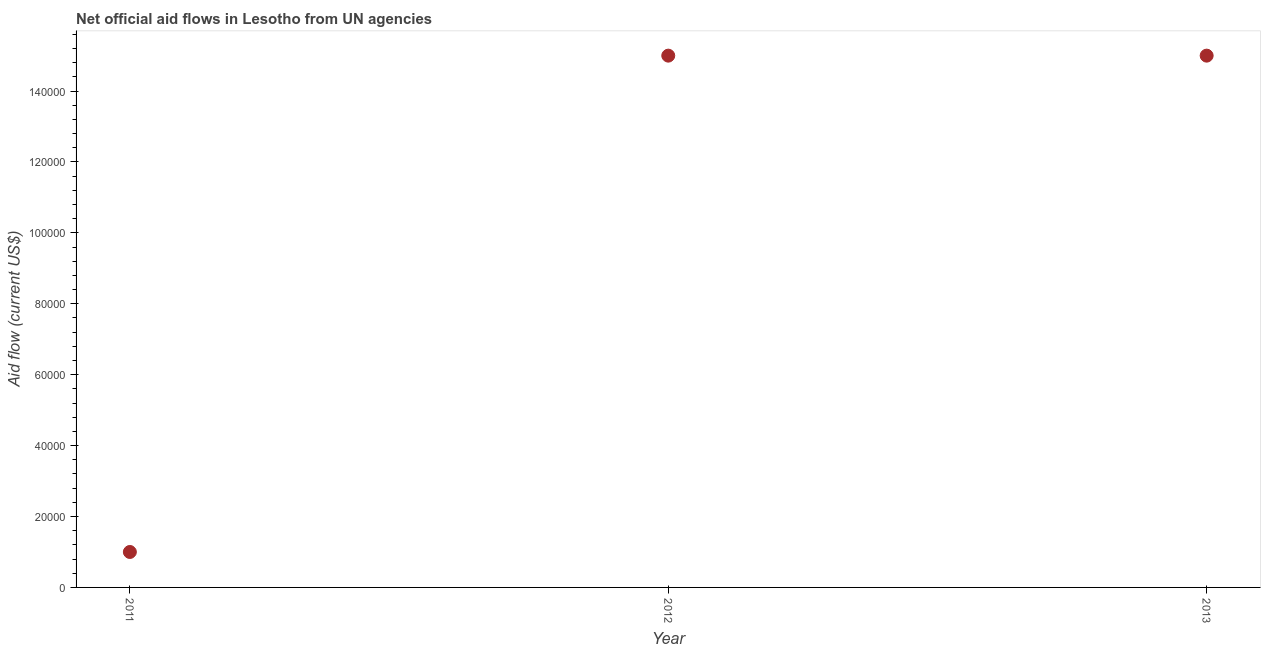What is the net official flows from un agencies in 2013?
Provide a succinct answer. 1.50e+05. Across all years, what is the maximum net official flows from un agencies?
Offer a very short reply. 1.50e+05. Across all years, what is the minimum net official flows from un agencies?
Your response must be concise. 10000. In which year was the net official flows from un agencies maximum?
Give a very brief answer. 2012. What is the sum of the net official flows from un agencies?
Offer a terse response. 3.10e+05. What is the difference between the net official flows from un agencies in 2011 and 2013?
Offer a very short reply. -1.40e+05. What is the average net official flows from un agencies per year?
Your answer should be very brief. 1.03e+05. In how many years, is the net official flows from un agencies greater than 84000 US$?
Offer a very short reply. 2. Do a majority of the years between 2011 and 2012 (inclusive) have net official flows from un agencies greater than 52000 US$?
Keep it short and to the point. No. What is the ratio of the net official flows from un agencies in 2011 to that in 2013?
Offer a terse response. 0.07. Is the net official flows from un agencies in 2012 less than that in 2013?
Make the answer very short. No. Is the sum of the net official flows from un agencies in 2012 and 2013 greater than the maximum net official flows from un agencies across all years?
Offer a very short reply. Yes. What is the difference between the highest and the lowest net official flows from un agencies?
Offer a terse response. 1.40e+05. How many years are there in the graph?
Your answer should be very brief. 3. What is the difference between two consecutive major ticks on the Y-axis?
Make the answer very short. 2.00e+04. Are the values on the major ticks of Y-axis written in scientific E-notation?
Your response must be concise. No. Does the graph contain any zero values?
Keep it short and to the point. No. What is the title of the graph?
Keep it short and to the point. Net official aid flows in Lesotho from UN agencies. What is the label or title of the X-axis?
Make the answer very short. Year. What is the label or title of the Y-axis?
Your answer should be compact. Aid flow (current US$). What is the Aid flow (current US$) in 2012?
Offer a very short reply. 1.50e+05. What is the difference between the Aid flow (current US$) in 2011 and 2012?
Offer a terse response. -1.40e+05. What is the difference between the Aid flow (current US$) in 2011 and 2013?
Give a very brief answer. -1.40e+05. What is the difference between the Aid flow (current US$) in 2012 and 2013?
Provide a short and direct response. 0. What is the ratio of the Aid flow (current US$) in 2011 to that in 2012?
Your answer should be compact. 0.07. What is the ratio of the Aid flow (current US$) in 2011 to that in 2013?
Make the answer very short. 0.07. 